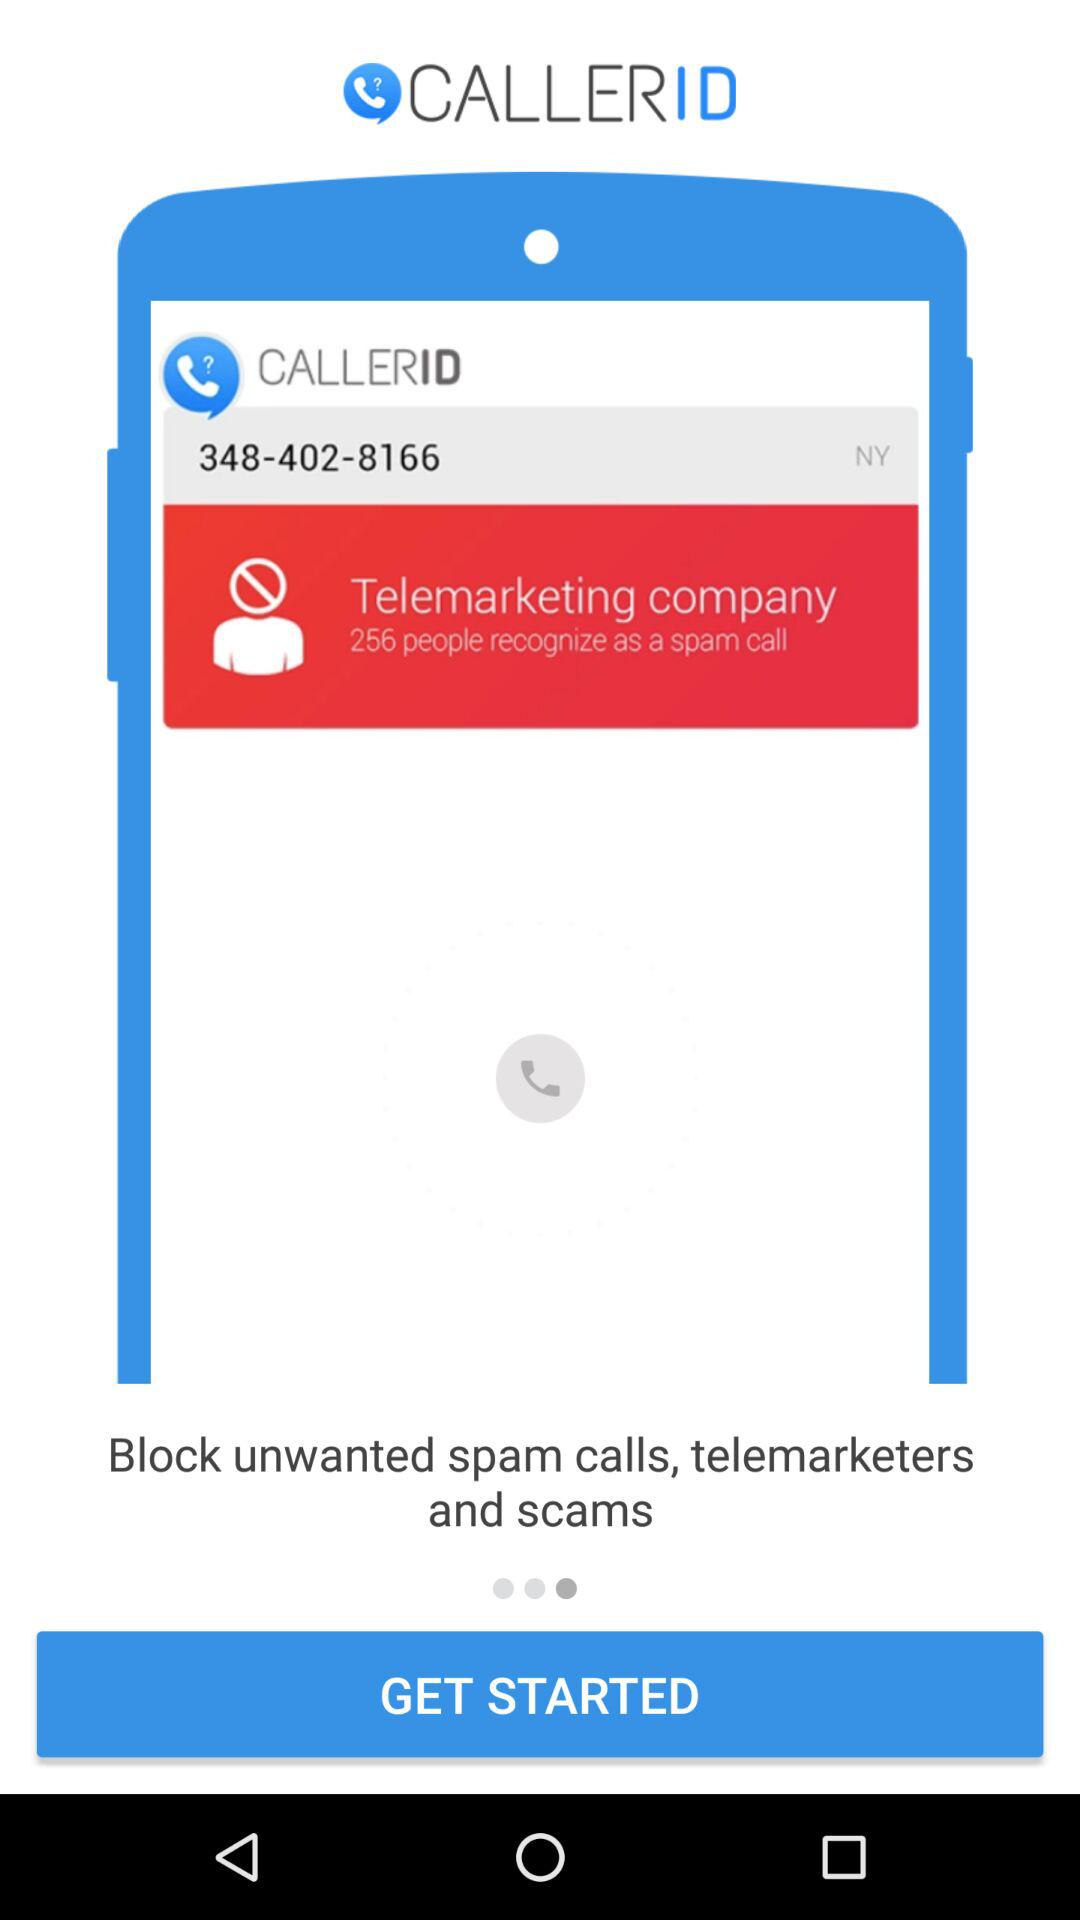What is the given phone number? The given phone number is 348-402-8166. 